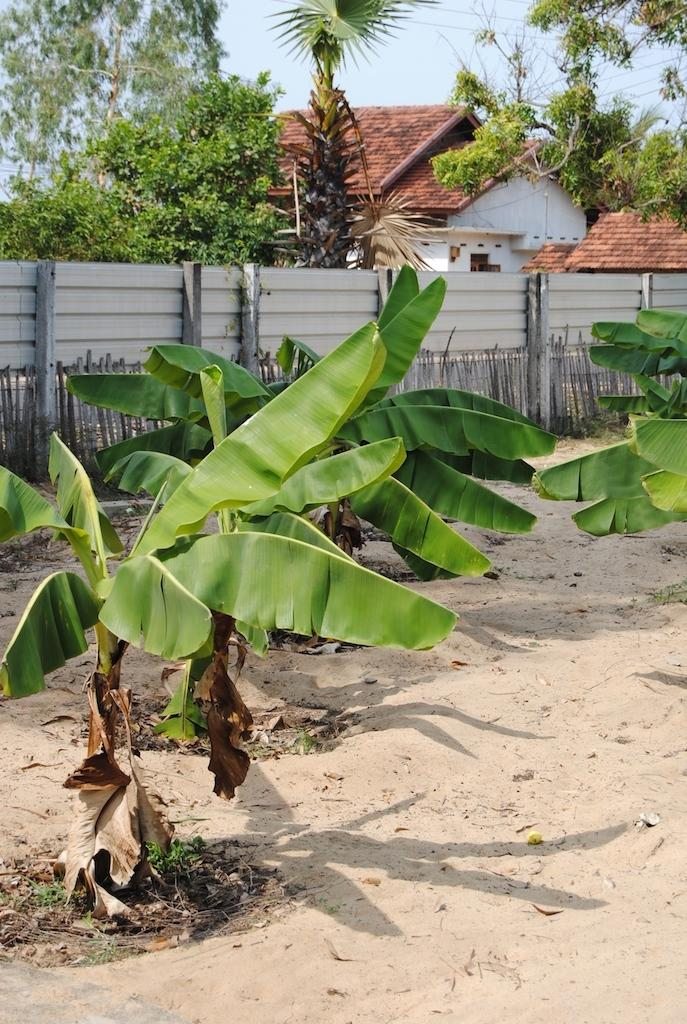What type of natural elements can be seen in the image? There are trees and plants in the image. What type of man-made structures are present in the image? There are houses in the image. What type of barrier can be seen in the image? There is a fence in the image. What is visible at the bottom of the image? The ground is visible at the bottom of the image. Can you tell me how many cactus are supporting the houses in the image? There are no cactus present in the image, and they are not supporting any houses. What type of station is visible in the image? There is no station present in the image. 